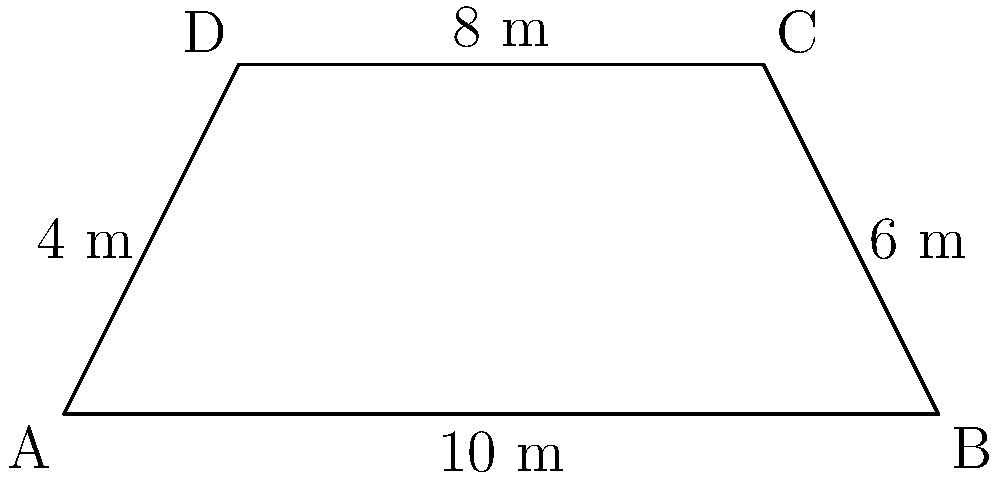Your new shrimp net has a trapezoid shape. The bottom edge measures 10 meters, the top edge is 8 meters, and the height is 4 meters. What is the area of this shrimp net in square meters? To find the area of a trapezoid, we use the formula:

$$A = \frac{1}{2}(b_1 + b_2)h$$

Where:
$A$ = Area
$b_1$ = Length of one parallel side
$b_2$ = Length of the other parallel side
$h$ = Height (perpendicular distance between the parallel sides)

Given:
$b_1 = 10$ m (bottom edge)
$b_2 = 8$ m (top edge)
$h = 4$ m (height)

Let's substitute these values into the formula:

$$A = \frac{1}{2}(10 + 8) \times 4$$

$$A = \frac{1}{2}(18) \times 4$$

$$A = 9 \times 4$$

$$A = 36$$

Therefore, the area of the shrimp net is 36 square meters.
Answer: 36 m² 